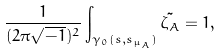Convert formula to latex. <formula><loc_0><loc_0><loc_500><loc_500>\frac { 1 } { ( 2 \pi \sqrt { - 1 } ) ^ { 2 } } \int _ { \gamma _ { 0 } ( { s } , s _ { \mu _ { A } } ) } \tilde { \zeta _ { A } } = 1 ,</formula> 